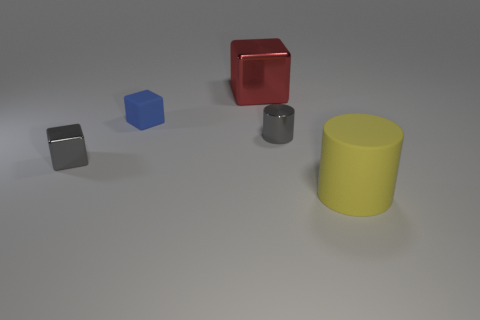Add 1 tiny red metal spheres. How many objects exist? 6 Subtract all cubes. How many objects are left? 2 Add 5 gray cylinders. How many gray cylinders are left? 6 Add 2 tiny things. How many tiny things exist? 5 Subtract 0 green cylinders. How many objects are left? 5 Subtract all tiny gray shiny things. Subtract all rubber cylinders. How many objects are left? 2 